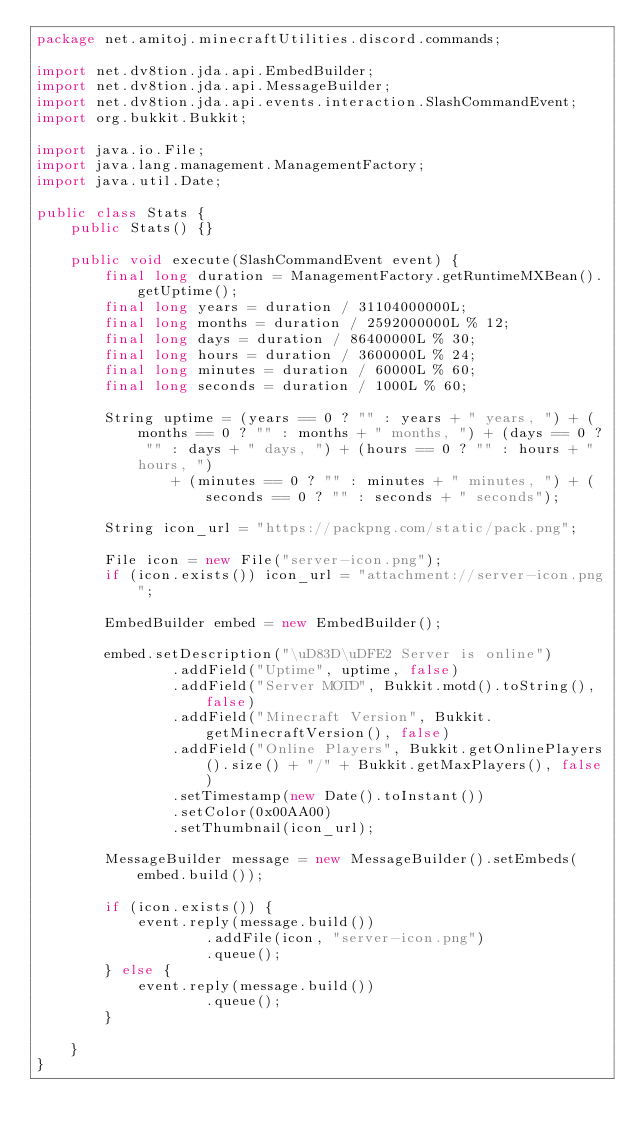<code> <loc_0><loc_0><loc_500><loc_500><_Java_>package net.amitoj.minecraftUtilities.discord.commands;

import net.dv8tion.jda.api.EmbedBuilder;
import net.dv8tion.jda.api.MessageBuilder;
import net.dv8tion.jda.api.events.interaction.SlashCommandEvent;
import org.bukkit.Bukkit;

import java.io.File;
import java.lang.management.ManagementFactory;
import java.util.Date;

public class Stats {
    public Stats() {}

    public void execute(SlashCommandEvent event) {
        final long duration = ManagementFactory.getRuntimeMXBean().getUptime();
        final long years = duration / 31104000000L;
        final long months = duration / 2592000000L % 12;
        final long days = duration / 86400000L % 30;
        final long hours = duration / 3600000L % 24;
        final long minutes = duration / 60000L % 60;
        final long seconds = duration / 1000L % 60;

        String uptime = (years == 0 ? "" : years + " years, ") + (months == 0 ? "" : months + " months, ") + (days == 0 ? "" : days + " days, ") + (hours == 0 ? "" : hours + " hours, ")
                + (minutes == 0 ? "" : minutes + " minutes, ") + (seconds == 0 ? "" : seconds + " seconds");

        String icon_url = "https://packpng.com/static/pack.png";

        File icon = new File("server-icon.png");
        if (icon.exists()) icon_url = "attachment://server-icon.png";

        EmbedBuilder embed = new EmbedBuilder();

        embed.setDescription("\uD83D\uDFE2 Server is online")
                .addField("Uptime", uptime, false)
                .addField("Server MOTD", Bukkit.motd().toString(), false)
                .addField("Minecraft Version", Bukkit.getMinecraftVersion(), false)
                .addField("Online Players", Bukkit.getOnlinePlayers().size() + "/" + Bukkit.getMaxPlayers(), false)
                .setTimestamp(new Date().toInstant())
                .setColor(0x00AA00)
                .setThumbnail(icon_url);

        MessageBuilder message = new MessageBuilder().setEmbeds(embed.build());

        if (icon.exists()) {
            event.reply(message.build())
                    .addFile(icon, "server-icon.png")
                    .queue();
        } else {
            event.reply(message.build())
                    .queue();
        }

    }
}
</code> 